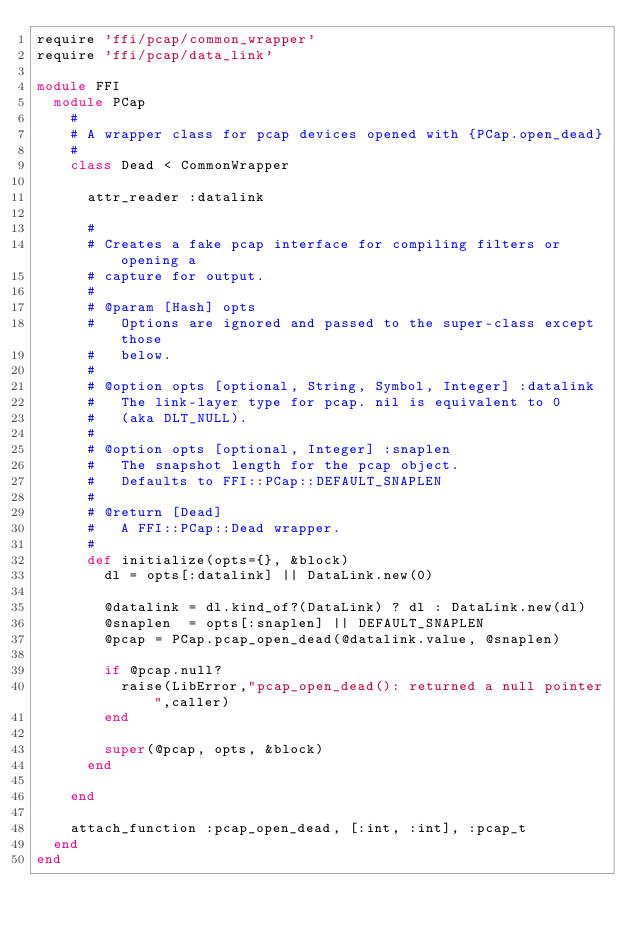Convert code to text. <code><loc_0><loc_0><loc_500><loc_500><_Ruby_>require 'ffi/pcap/common_wrapper'
require 'ffi/pcap/data_link'

module FFI
  module PCap
    #
    # A wrapper class for pcap devices opened with {PCap.open_dead}
    #
    class Dead < CommonWrapper

      attr_reader :datalink

      #
      # Creates a fake pcap interface for compiling filters or opening a
      # capture for output.
      #
      # @param [Hash] opts
      #   Options are ignored and passed to the super-class except those
      #   below.
      #
      # @option opts [optional, String, Symbol, Integer] :datalink
      #   The link-layer type for pcap. nil is equivalent to 0
      #   (aka DLT_NULL).
      #
      # @option opts [optional, Integer] :snaplen
      #   The snapshot length for the pcap object.
      #   Defaults to FFI::PCap::DEFAULT_SNAPLEN
      #
      # @return [Dead]
      #   A FFI::PCap::Dead wrapper.
      #
      def initialize(opts={}, &block)
        dl = opts[:datalink] || DataLink.new(0)

        @datalink = dl.kind_of?(DataLink) ? dl : DataLink.new(dl)
        @snaplen  = opts[:snaplen] || DEFAULT_SNAPLEN
        @pcap = PCap.pcap_open_dead(@datalink.value, @snaplen)

        if @pcap.null?
          raise(LibError,"pcap_open_dead(): returned a null pointer",caller)
        end

        super(@pcap, opts, &block)
      end

    end

    attach_function :pcap_open_dead, [:int, :int], :pcap_t
  end
end
</code> 